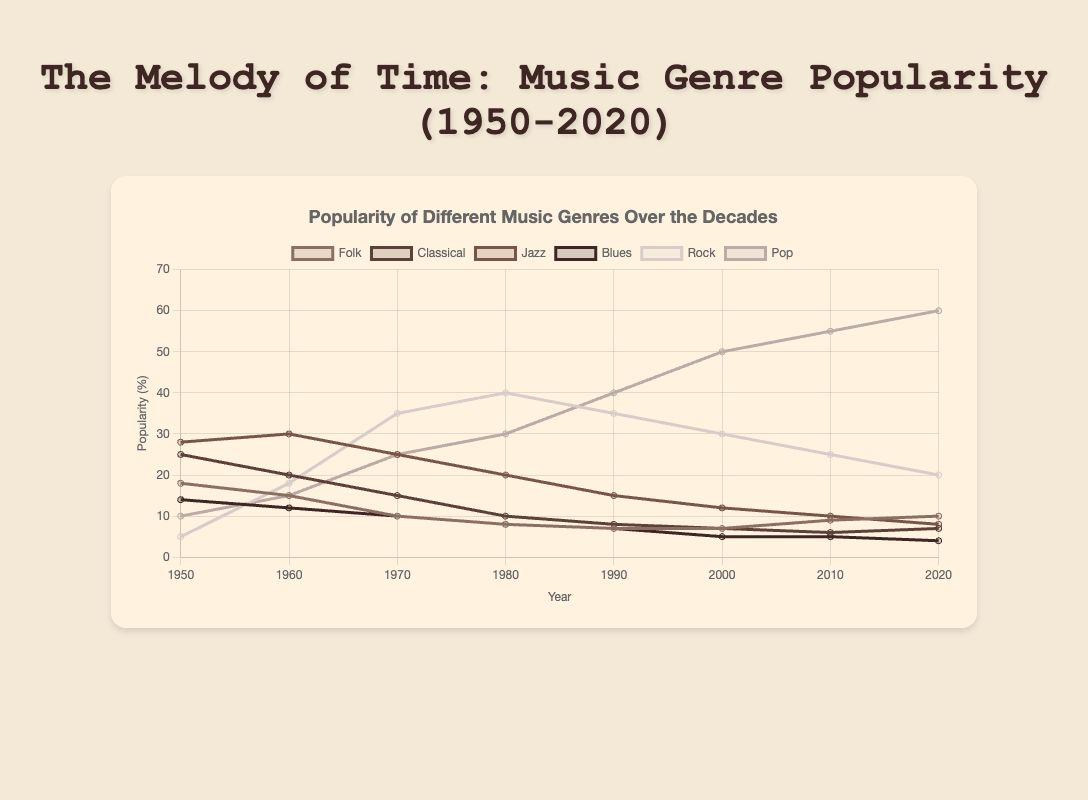What genre saw the highest popularity in 2020? In 2020, the line representing Pop music reaches the highest point compared to other lines, indicating its popularity was the highest.
Answer: Pop How did the popularity of Rock music change from 1950 to 2020? In 1950, Rock had a popularity of 5. Over the decades, it peaked at 40 in 1980 and then declined to 20 by 2020. The popularity first rose significantly and then gradually declined.
Answer: Increased then decreased Between which consecutive decades did Folk music maintain the most stable popularity? From 2000 to 2010, the popularity of Folk music was 7 and 9, respectively, indicating the smallest change (an increase of only 2) compared to other decades' changes.
Answer: 2000 to 2010 In which decade did Jazz music start to decline? Jazz music started to decline after its peak in 1960, where its popularity was 30, then it decreased to 25 in 1970 and continued decreasing each decade afterward.
Answer: 1960 What is the average popularity of Classical music over the decades? Sum the popularity values of Classical music across all decades (25 + 20 + 15 + 10 + 8 + 7 + 6 + 7) to get 98, then divide by the number of data points (8).
Answer: 12.25 Which genre consistently increased in popularity from 1950 to 2020? The line representing Pop music shows a continuous upward trend from 1950 to 2020, indicating its increasing popularity over the decades.
Answer: Pop In 1980, which genre had a greater popularity, Blues or Classical? By comparing the heights of the lines for Blues and Classical in 1980, it's clear that Classical (10) had a greater popularity than Blues (8).
Answer: Classical What is the difference in the popularity of Rock music between its peak and 2020? The peak popularity of Rock music was 40 in 1980, and in 2020 it was 20. The difference is 40 - 20 = 20.
Answer: 20 How did the popularity of Folk music change from 1950 to 1960? In 1950, Folk had a popularity of 18. By 1960, it decreased to 15. The change is 18 - 15 = -3.
Answer: Decreased by 3 Which genre had a higher popularity in 1970, Jazz or Pop? In 1970, comparing the lines for Jazz (25) and Pop (25), both reached the same height, indicating equal popularity.
Answer: Equal 